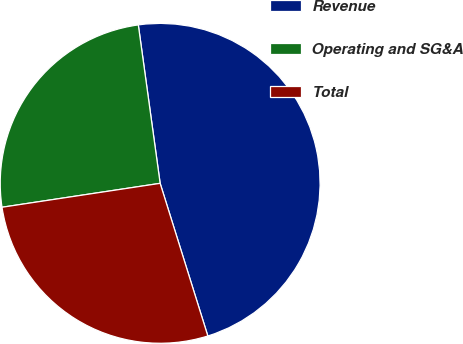<chart> <loc_0><loc_0><loc_500><loc_500><pie_chart><fcel>Revenue<fcel>Operating and SG&A<fcel>Total<nl><fcel>47.36%<fcel>25.21%<fcel>27.43%<nl></chart> 